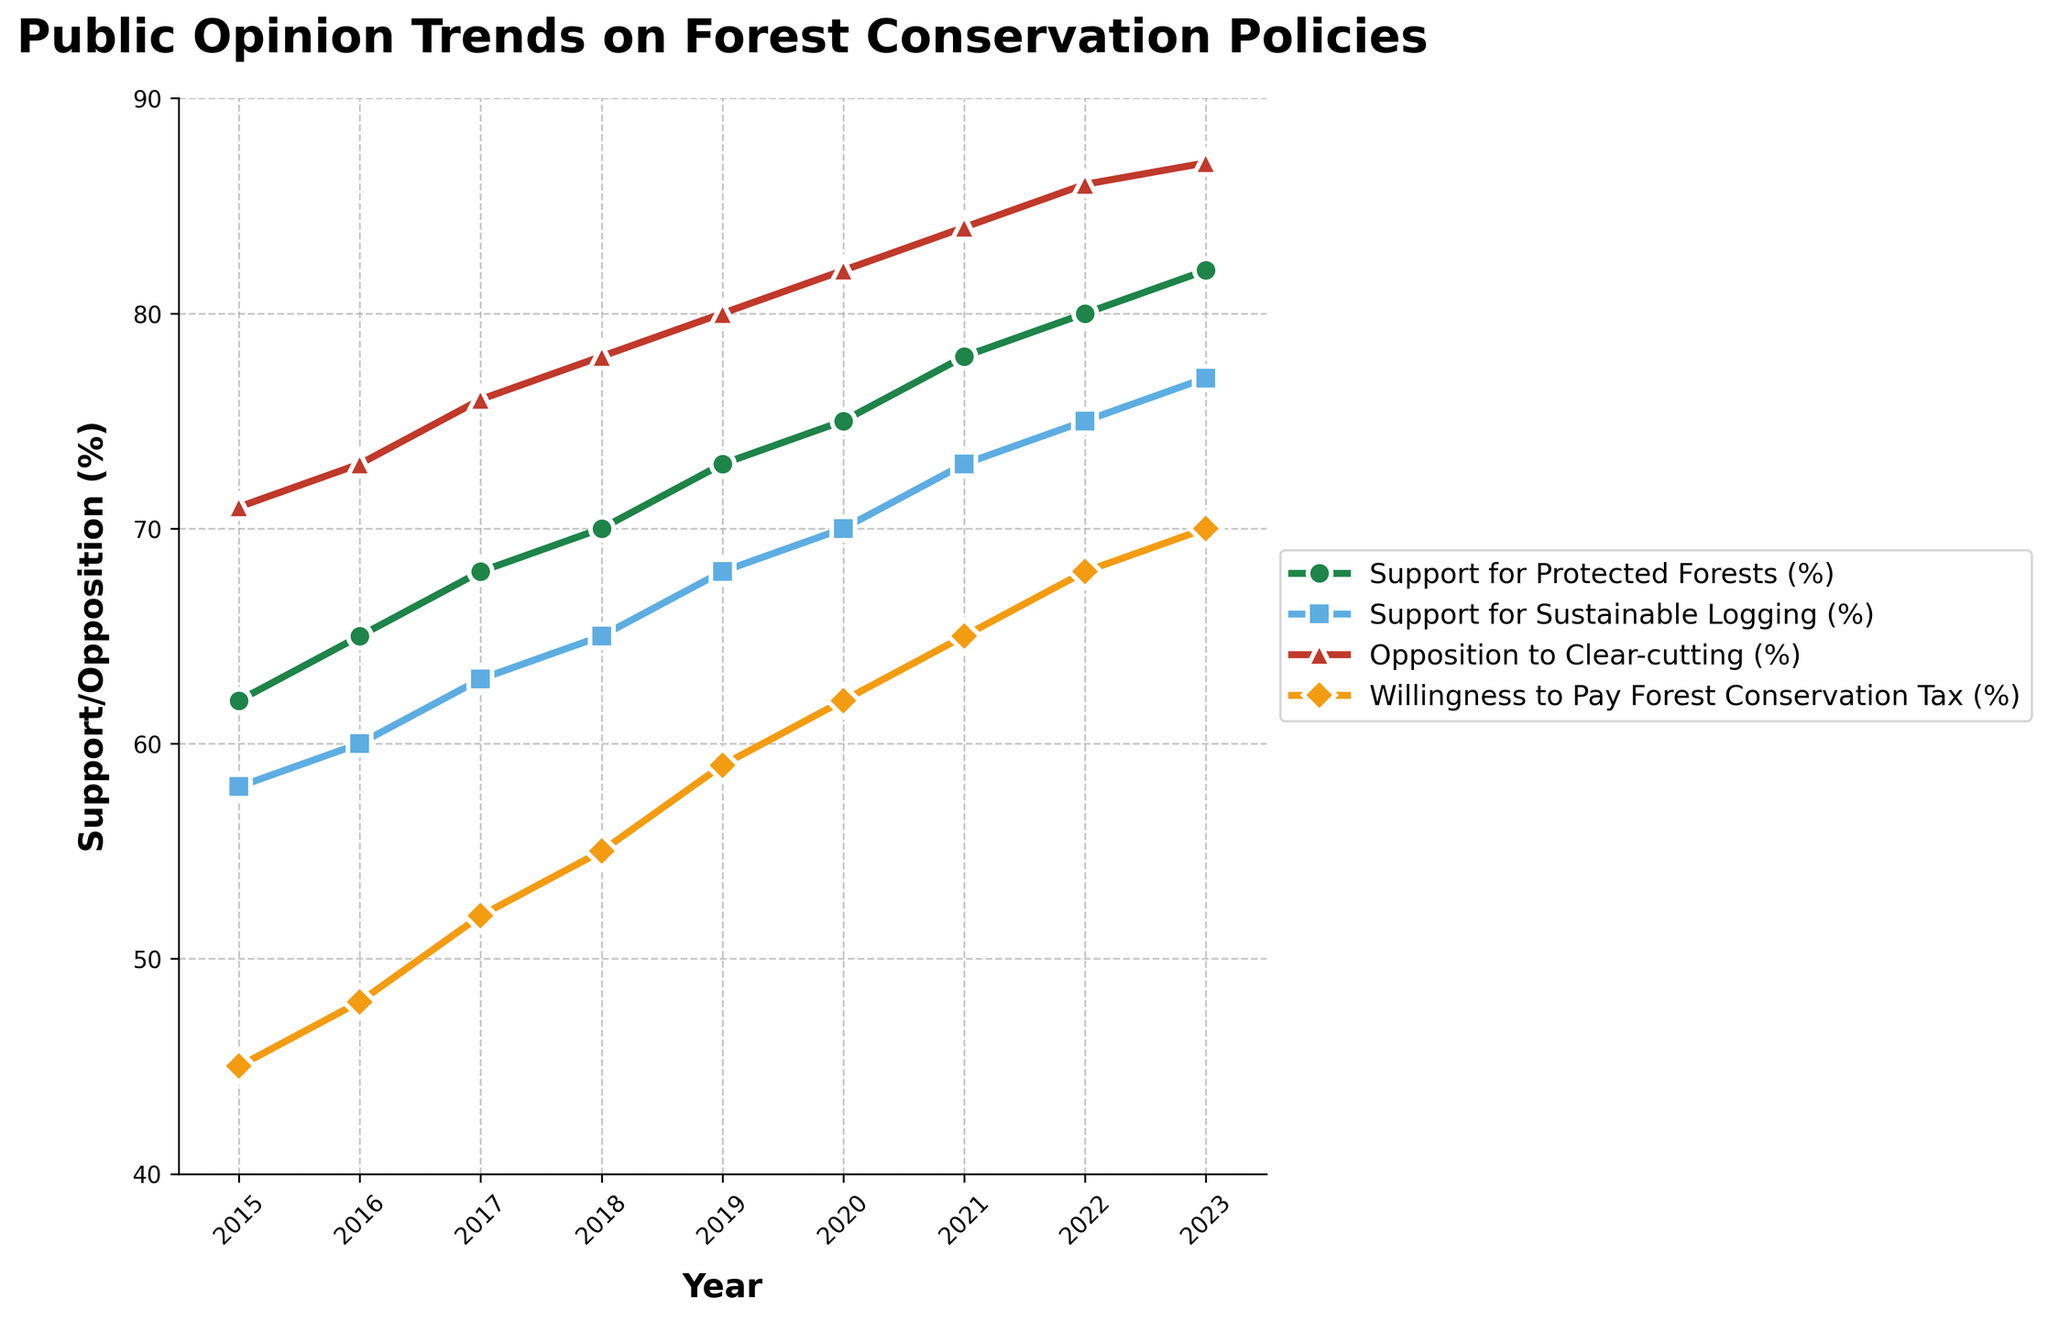What's the trend for 'Support for Protected Forests (%)' from 2015 to 2023? Observing the line representing 'Support for Protected Forests (%)', it shows a continual increase from 62% in 2015 to 82% in 2023.
Answer: An increasing trend Which year shows the highest 'Willingness to Pay Forest Conservation Tax (%)'? The line for 'Willingness to Pay Forest Conservation Tax (%)' peaks at 70% in the year 2023.
Answer: 2023 How much did 'Support for Sustainable Logging (%)' increase from 2015 to 2023? The value increased from 58% in 2015 to 77% in 2023. The difference is 77% - 58% = 19%.
Answer: 19% Is 'Opposition to Clear-cutting (%)' consistently higher than 'Support for Sustainable Logging (%)' throughout the years? By looking at both lines, 'Opposition to Clear-cutting (%)' is always above 'Support for Sustainable Logging (%)' from 2015 to 2023.
Answer: Yes Between 2018 and 2019, which segment saw the smallest increase in support or opposition? By comparing the differences, 'Support for Protected Forests (%)' increased by 3% (70% to 73%), 'Support for Sustainable Logging (%)' increased by 3% (65% to 68%), 'Opposition to Clear-cutting (%)' increased by 2% (78% to 80%), and 'Willingness to Pay Forest Conservation Tax (%)' increased by 4% (55% to 59%). The smallest increase was for 'Opposition to Clear-cutting (%)'.
Answer: Opposition to Clear-cutting (%) Which visual marker indicates 'Support for Protected Forests (%)'? The 'Support for Protected Forests (%)' is indicated by the line with circular markers.
Answer: Circular markers What is the average support for 'Sustainable Logging (%)' from 2015 to 2023? The values are 58, 60, 63, 65, 68, 70, 73, 75, and 77. The sum is 609. There are 9 years, so the average is 609 / 9 = 67.67%.
Answer: 67.67% Which category shows the highest end value in 2023? In 2023, 'Opposition to Clear-cutting (%)' has the highest value at 87%.
Answer: Opposition to Clear-cutting (%) Does any category experience a decrease in any year? By examining the lines, none of the categories have a decrease in any year; they all show an upward trend.
Answer: No What is the difference in 'Support for Protected Forests (%)' between 2017 and 2022? In 2017, the value is 68%, and in 2022, it's 80%. The difference is 80% - 68% = 12%.
Answer: 12% 